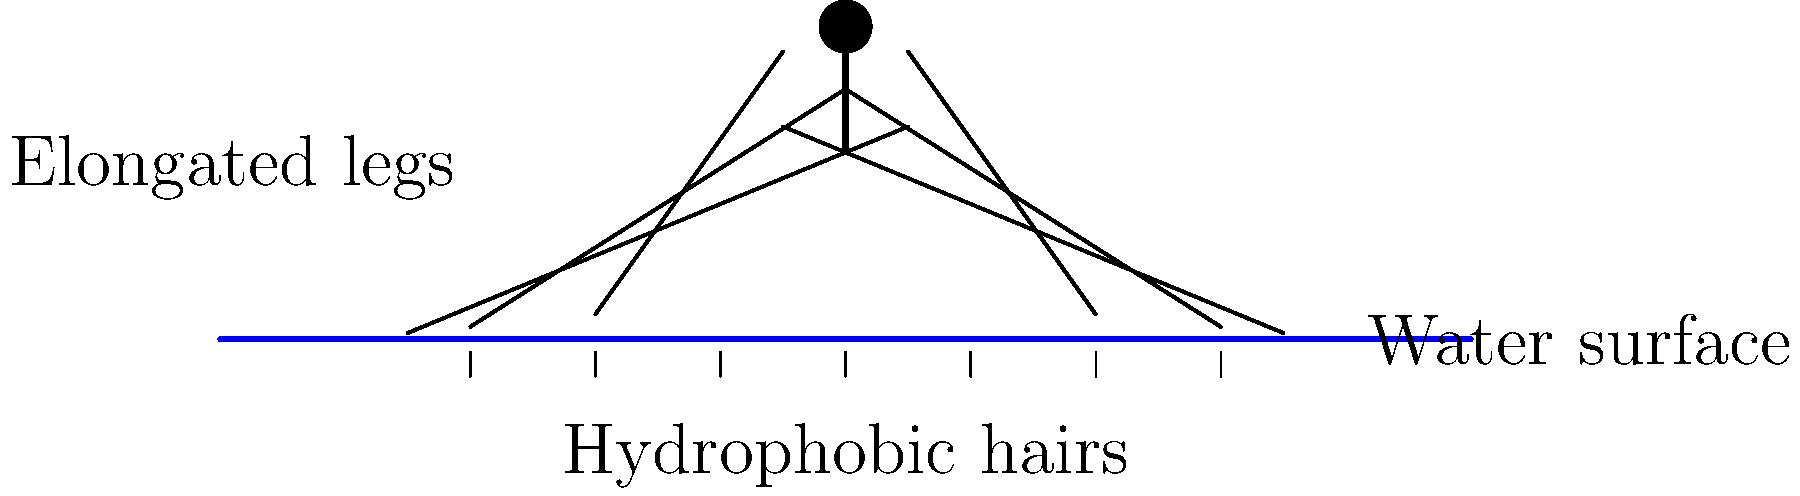Explain how the morphological adaptations of water striders, as shown in the illustration, enable them to effectively utilize surface tension for locomotion on water. Discuss at least three specific adaptations and their functions. 1. Hydrophobic hairs:
   - Water striders have microscopic hydrophobic hairs covering their legs and body.
   - These hairs repel water molecules, creating a small air pocket between the insect and the water surface.
   - This adaptation prevents the insect from breaking through the water surface tension.

2. Elongated legs:
   - Water striders possess disproportionately long legs compared to their body size.
   - The legs distribute the insect's weight over a larger surface area, reducing pressure on any single point.
   - This adaptation allows them to stay above the water surface without breaking through.

3. Leg positioning:
   - The middle pair of legs is typically the longest and acts as oars for propulsion.
   - The front and hind legs are used for steering and stability.
   - This arrangement enables efficient movement across the water surface.

4. Lightweight body:
   - Water striders have a slender, lightweight body structure.
   - This reduces their overall mass, making it easier to stay afloat on the water surface.
   - The low weight also contributes to their ability to move quickly and efficiently.

5. Specialized leg tips:
   - The tips of their legs have specialized structures that increase surface area contact with the water.
   - These structures help in distributing weight and improving traction on the water surface.

6. Flexible leg joints:
   - Water striders have flexible leg joints that allow for rapid, skating-like movements.
   - This flexibility enables them to navigate effectively on the water surface and evade predators.

These adaptations work together to allow water striders to exploit surface tension for locomotion, making them highly successful in their aquatic habitat.
Answer: Hydrophobic hairs, elongated legs, and specialized leg positioning 